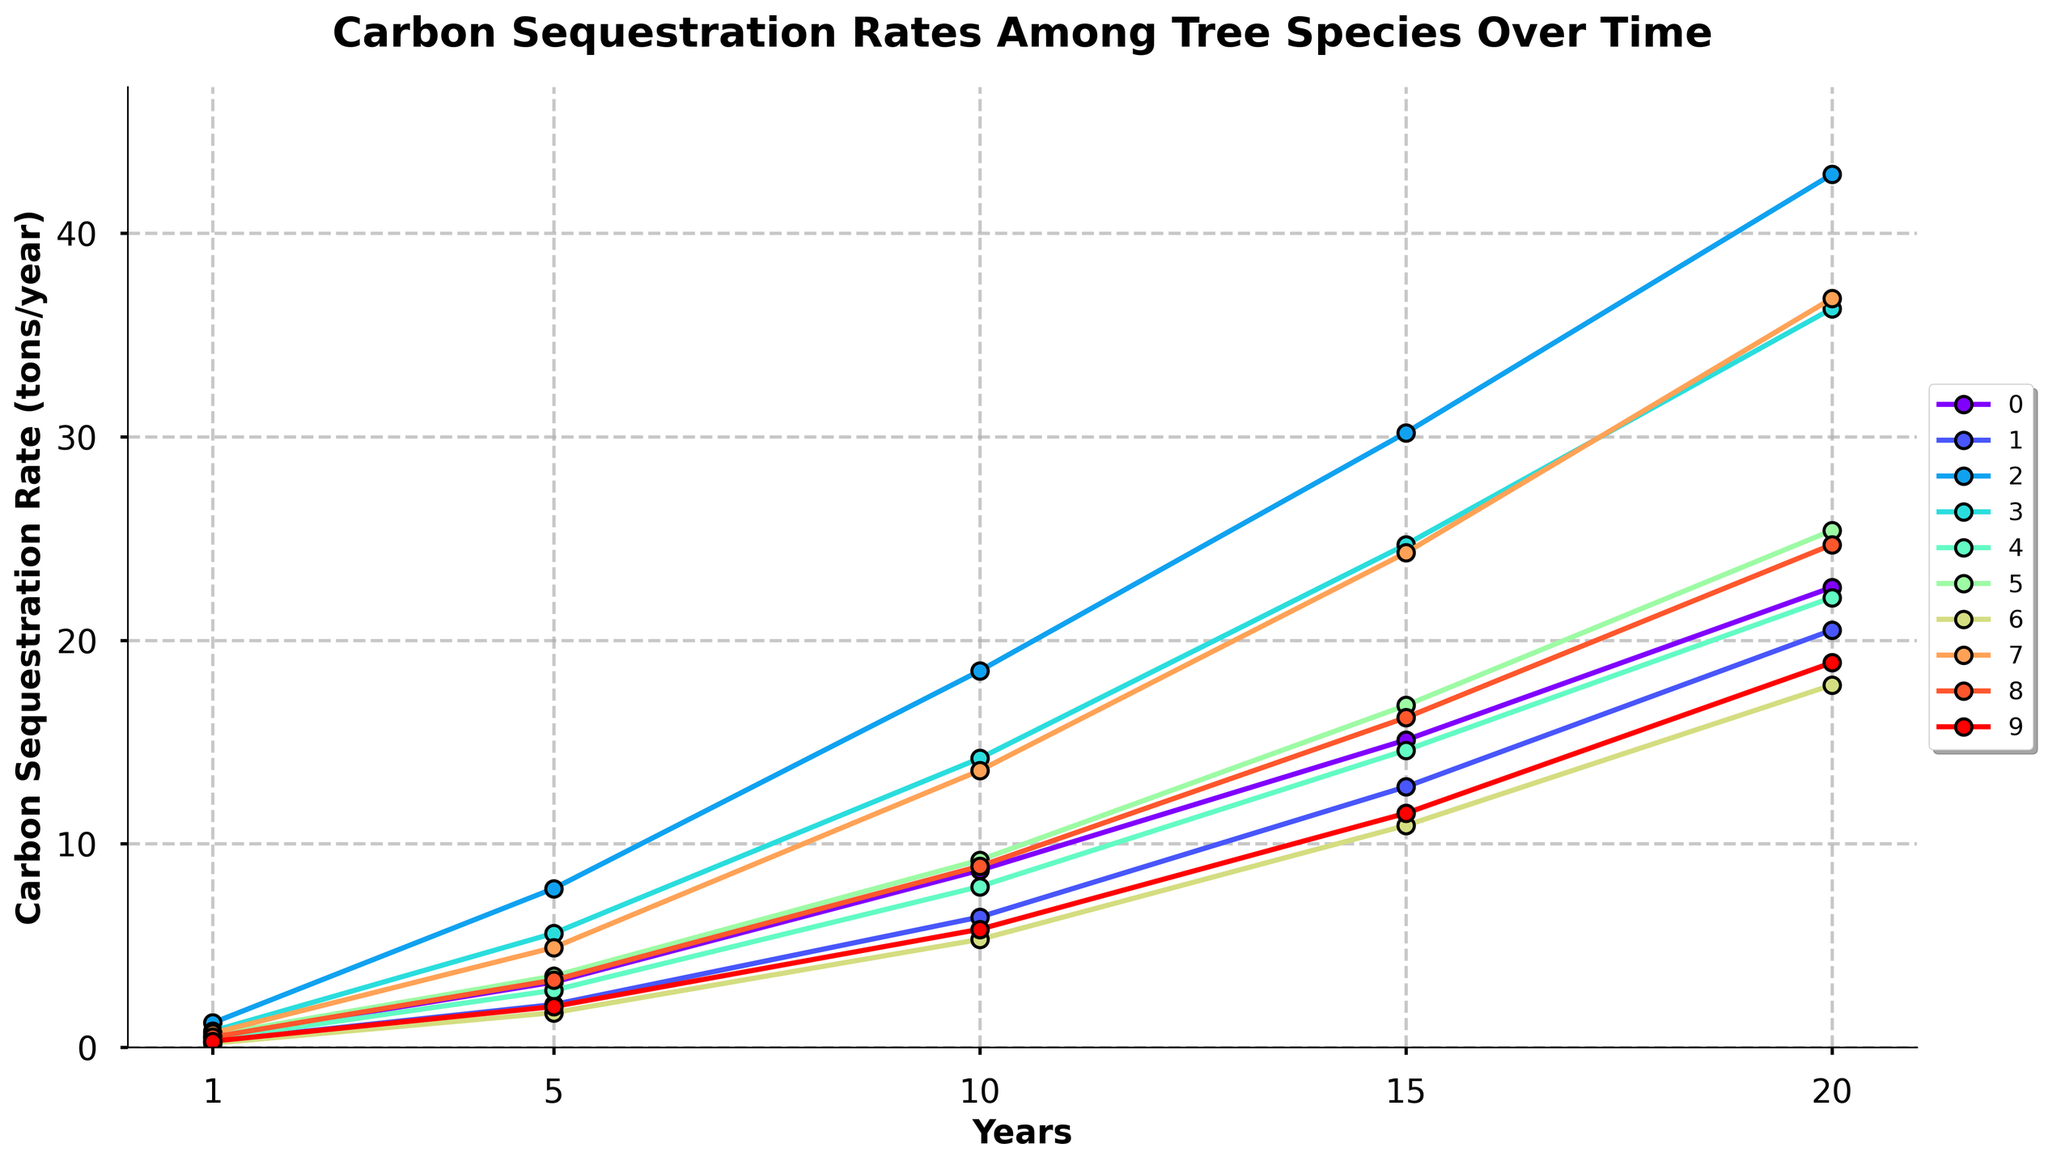What's the carbon sequestration rate for Douglas Fir at Year 10? Locate the Douglas Fir line on the graph and find its value at the Year 10 mark on the x-axis. The corresponding y-axis value indicates the carbon sequestration rate.
Answer: 8.7 tons/year Which tree species has the highest carbon sequestration rate by Year 20? Identify each tree species' line at the Year 20 mark on the x-axis. The line reaching the highest point on the y-axis represents the species with the highest carbon sequestration rate.
Answer: Eucalyptus By how much did the carbon sequestration rate increase for Poplar from Year 5 to Year 15? Locate the values for Poplar at Year 5 (5.6) and Year 15 (24.7). Subtract the Year 5 value from the Year 15 value to find the increase.
Answer: 19.1 tons/year Which tree species shows the most significant increase in carbon sequestration rate between Year 10 and Year 20? Identify the Year 10 and Year 20 values for all species, then calculate the differences. The species with the largest difference has the most significant increase.
Answer: Eucalyptus Compare the carbon sequestration rates of the Giant Sequoia and American Beech at Year 10. Which one is higher and by how much? Locate the values at Year 10 for both Giant Sequoia (13.6) and American Beech (5.8). Subtract the American Beech rate from the Giant Sequoia rate to determine the difference.
Answer: Giant Sequoia; 7.8 tons/year What is the average carbon sequestration rate for Sugar Maple from Year 1 to Year 20? Sum the values for Sugar Maple at each time point (0.2, 1.7, 5.3, 10.9, 17.8) and divide by the number of time points (5) to find the average.
Answer: 7.18 tons/year How does the carbon sequestration rate of Eucalyptus compare to Douglas Fir at Year 5? Find the Year 5 values for both Eucalyptus (7.8) and Douglas Fir (3.2). Compare the two values to see that Eucalyptus has a higher rate.
Answer: Eucalyptus is higher by 4.6 tons/year Which species has the smallest increase in carbon sequestration rate from Year 1 to Year 5? Calculate the increase for each species by subtracting the Year 1 value from the Year 5 value. The species with the smallest increase is the one we are interested in.
Answer: Sugar Maple What is the ratio of the carbon sequestration rate of Norway Spruce to Loblolly Pine at Year 20? Locate the values at Year 20 for both Norway Spruce (25.4) and Loblolly Pine (22.1). Divide the Norway Spruce value by the Loblolly Pine value to find the ratio.
Answer: 25.4 / 22.1 = 1.15 What trend do you observe in the carbon sequestration rate of the Sitka Spruce over the 20-year period? Follow the Sitka Spruce line across the time points and observe the increase at each point. The line shows a steady rise in the carbon sequestration rate.
Answer: Steady increase 